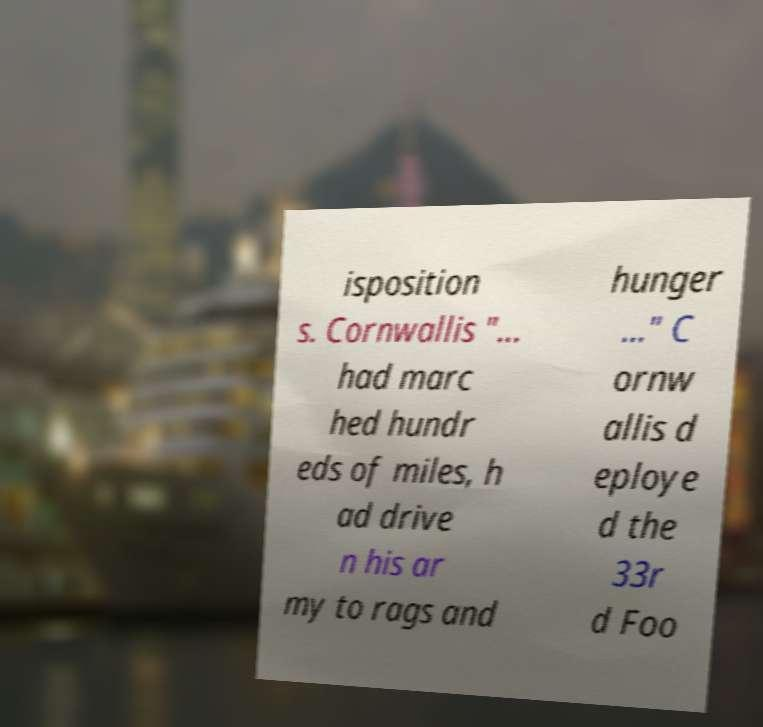Can you accurately transcribe the text from the provided image for me? isposition s. Cornwallis "... had marc hed hundr eds of miles, h ad drive n his ar my to rags and hunger ..." C ornw allis d eploye d the 33r d Foo 